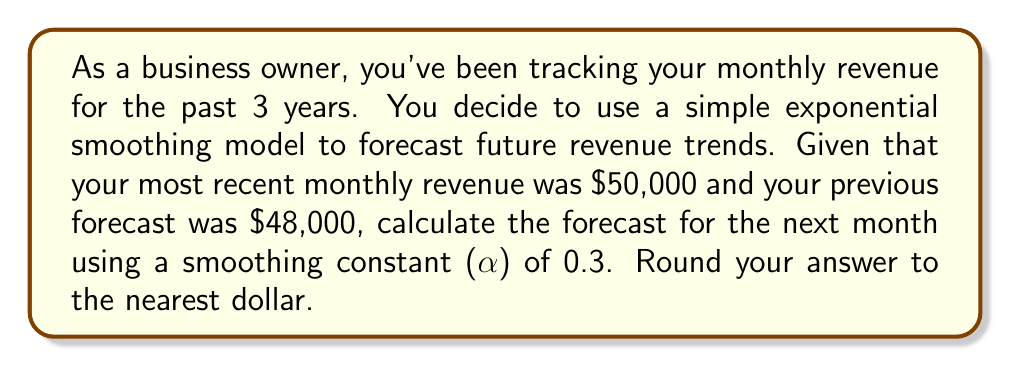Show me your answer to this math problem. To solve this problem, we'll use the simple exponential smoothing formula:

$$F_{t+1} = \alpha Y_t + (1-\alpha)F_t$$

Where:
$F_{t+1}$ is the forecast for the next period
$\alpha$ is the smoothing constant (0.3 in this case)
$Y_t$ is the actual value for the current period ($50,000)
$F_t$ is the forecast for the current period ($48,000)

Let's substitute these values into the formula:

$$F_{t+1} = 0.3 \times 50,000 + (1-0.3) \times 48,000$$

Now, let's solve step by step:

1. Calculate the first part: $0.3 \times 50,000 = 15,000$
2. Calculate $(1-0.3) = 0.7$
3. Calculate the second part: $0.7 \times 48,000 = 33,600$
4. Sum the two parts: $15,000 + 33,600 = 48,600$

Therefore, the forecast for the next month is $48,600.
Answer: $48,600 